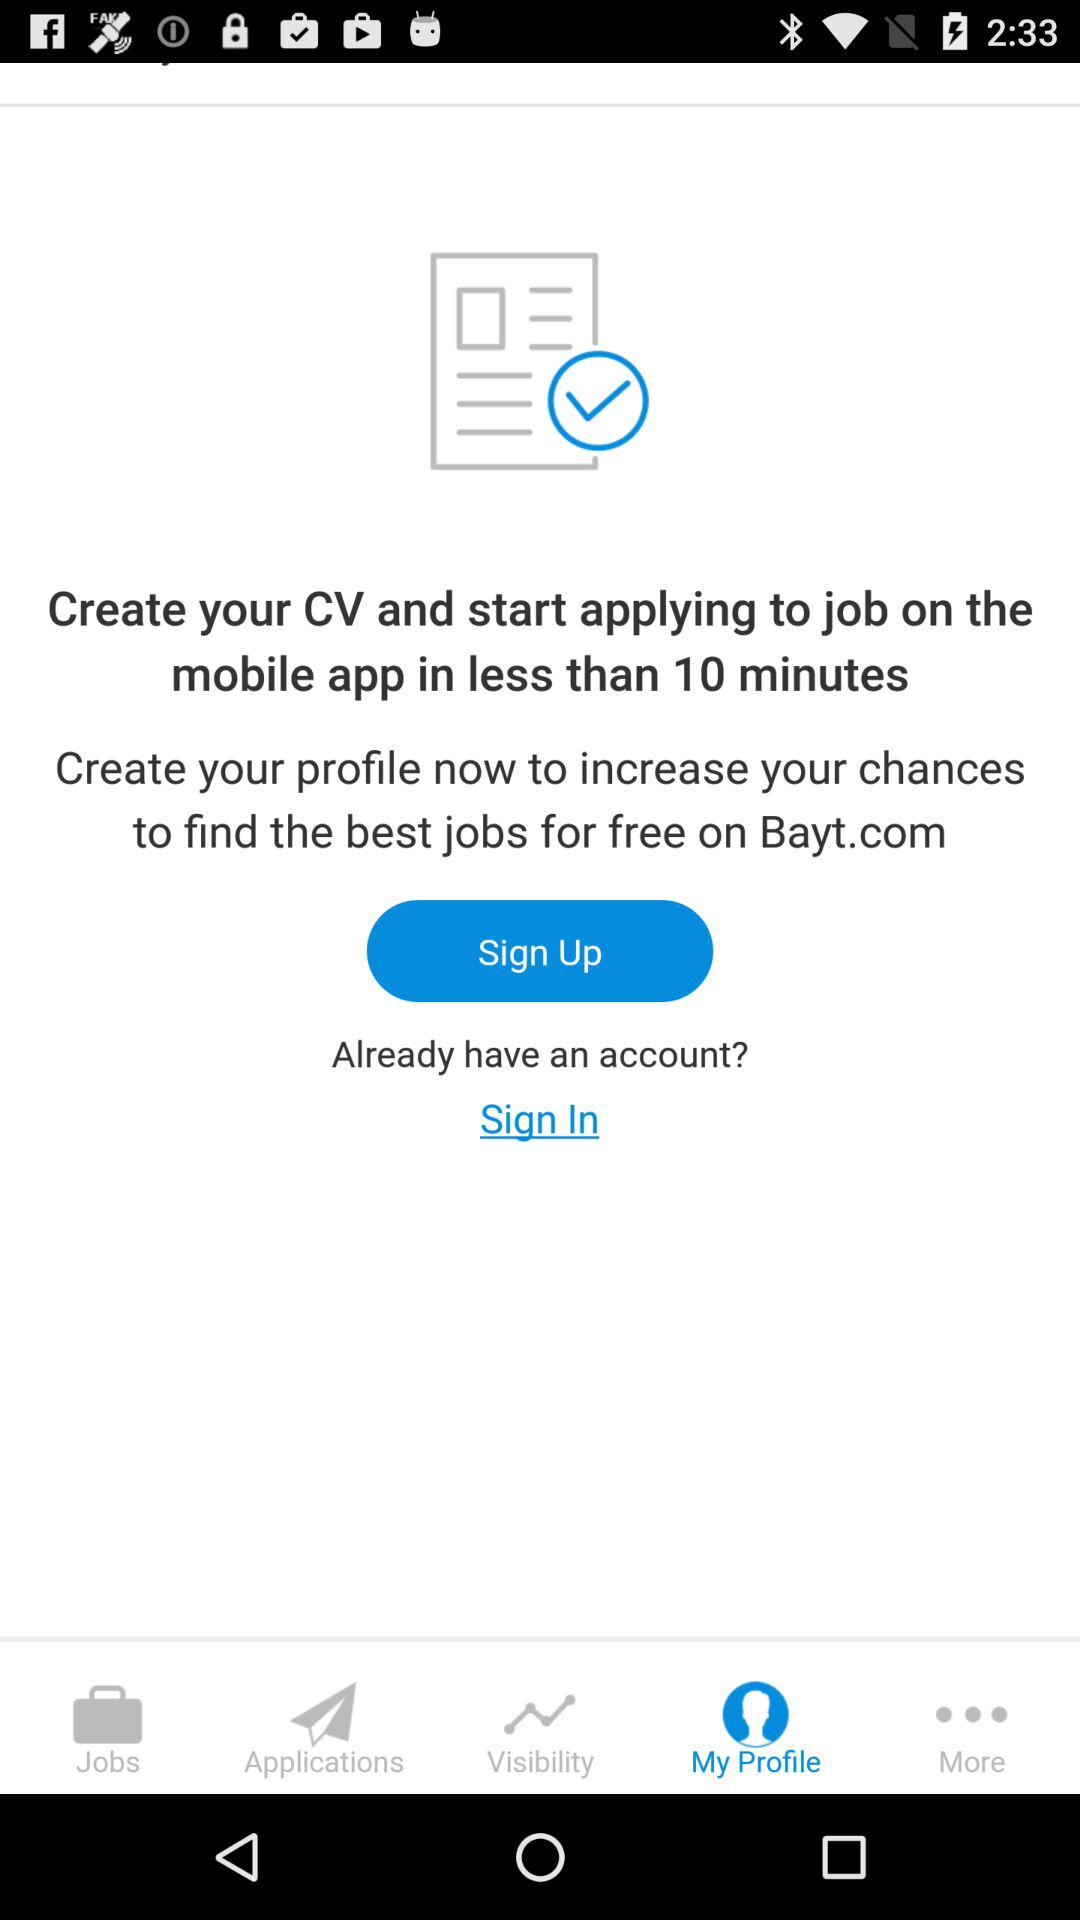How much time will it take to create a CV and apply for a job? The time it takes to create a CV and apply for a job is less than 10 minutes. 